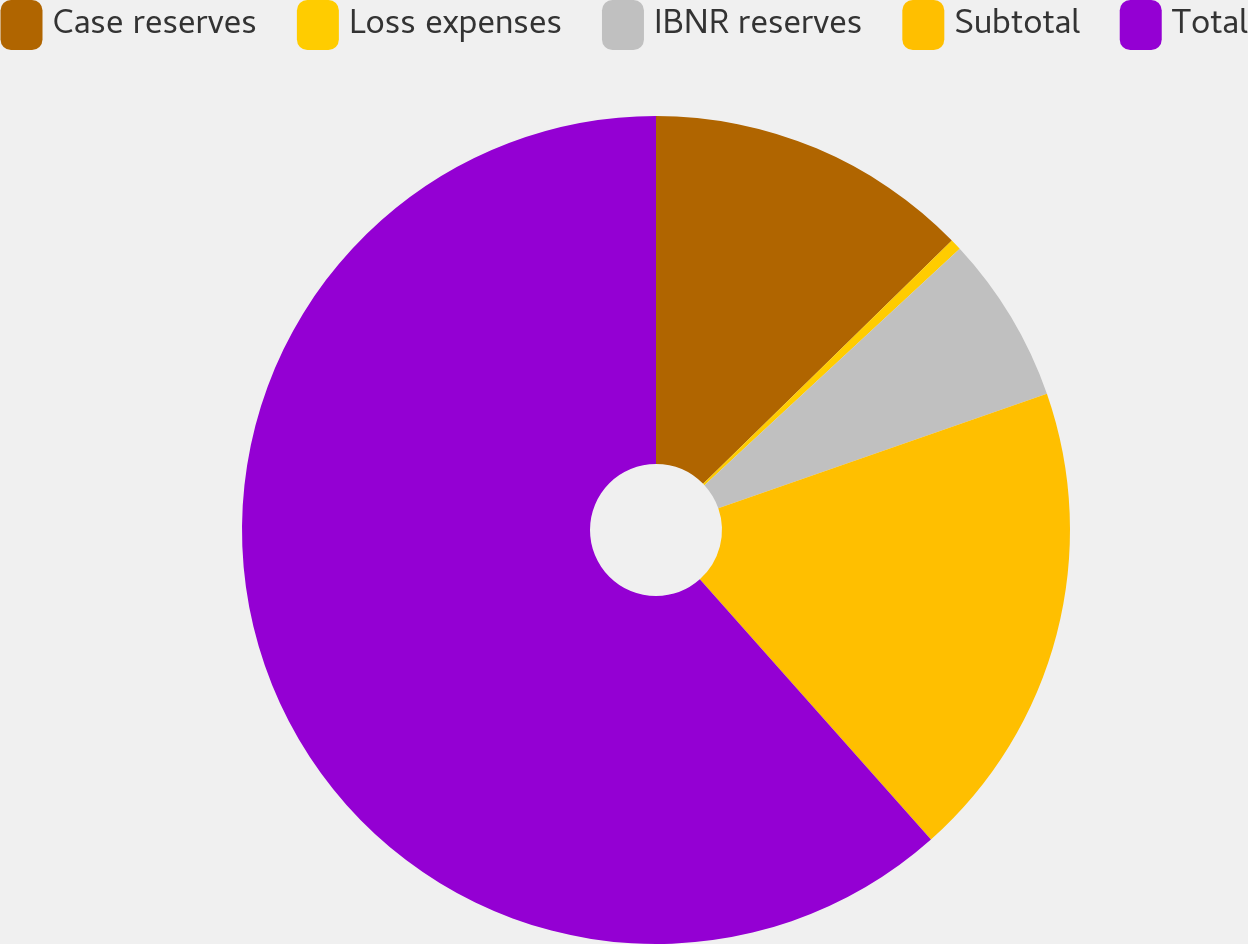<chart> <loc_0><loc_0><loc_500><loc_500><pie_chart><fcel>Case reserves<fcel>Loss expenses<fcel>IBNR reserves<fcel>Subtotal<fcel>Total<nl><fcel>12.67%<fcel>0.44%<fcel>6.55%<fcel>18.78%<fcel>61.56%<nl></chart> 